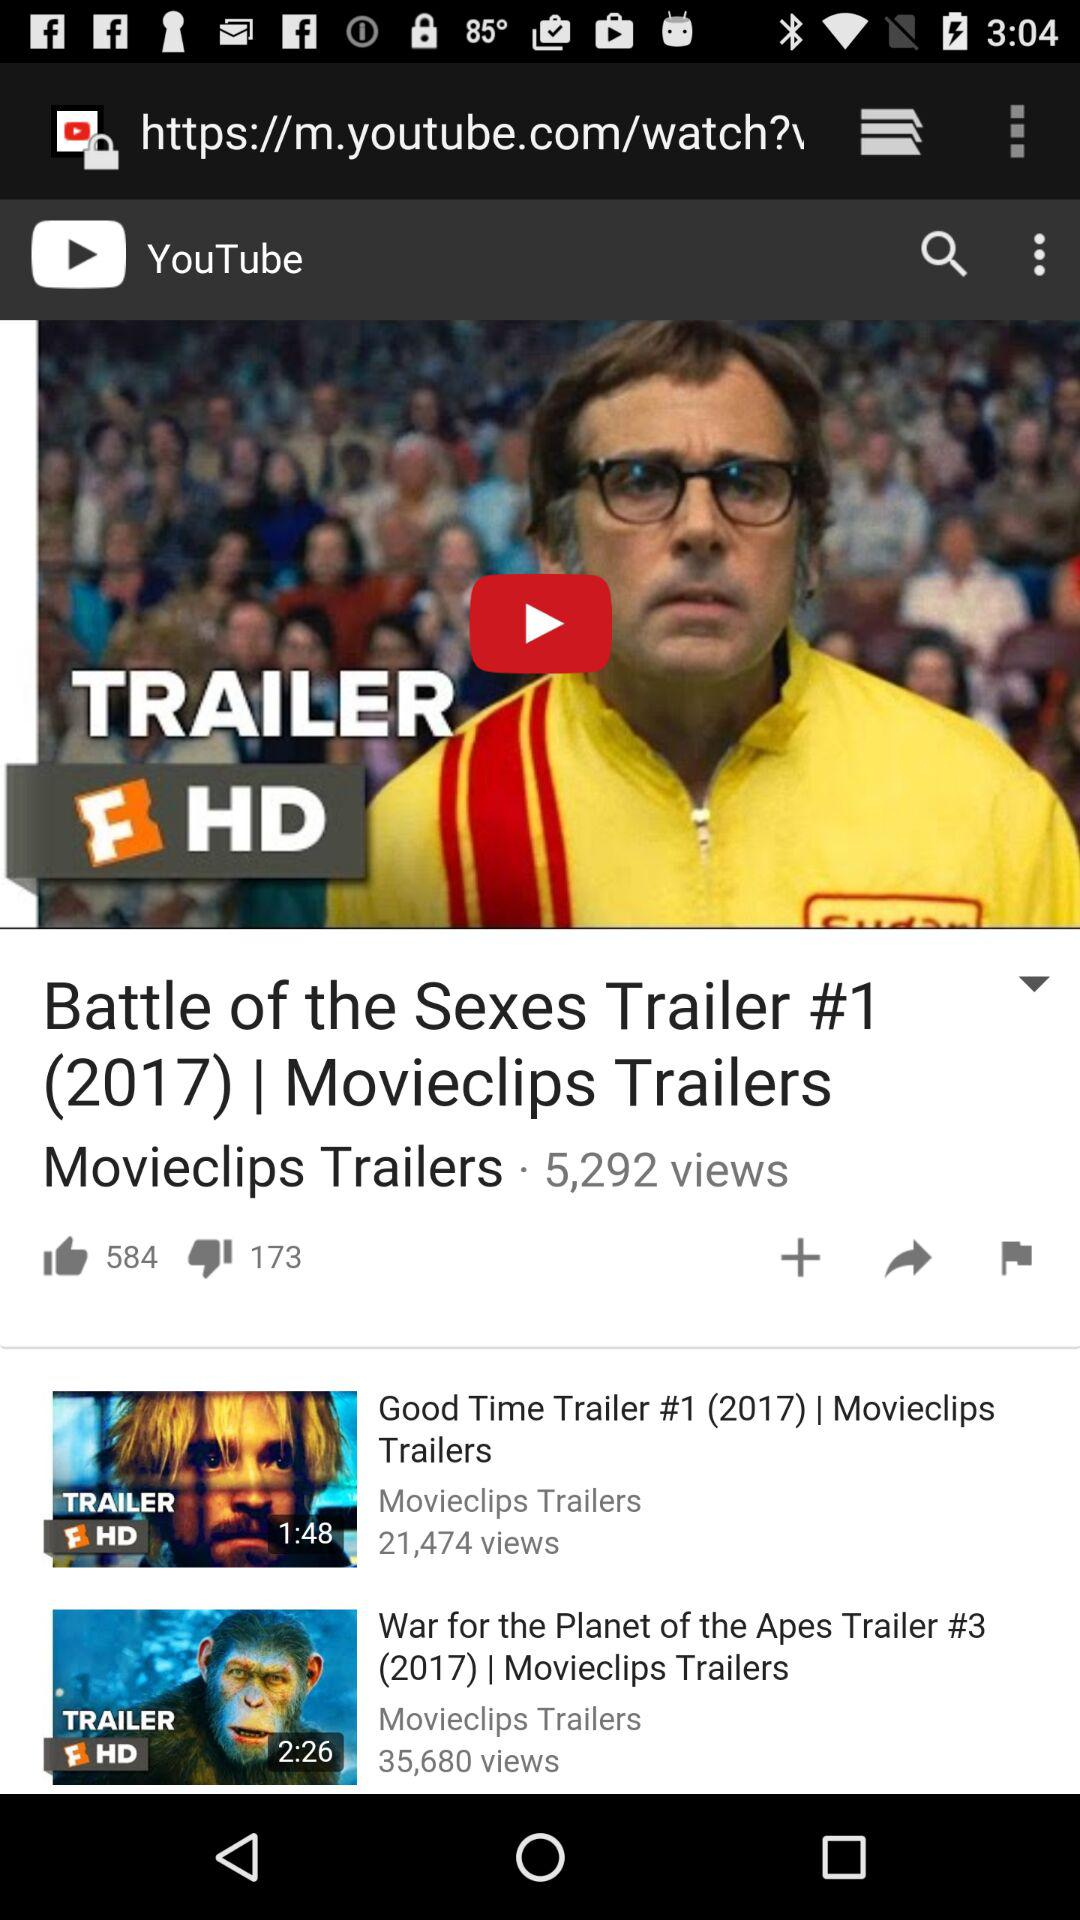How many likes did the video get? The video got 584 likes. 